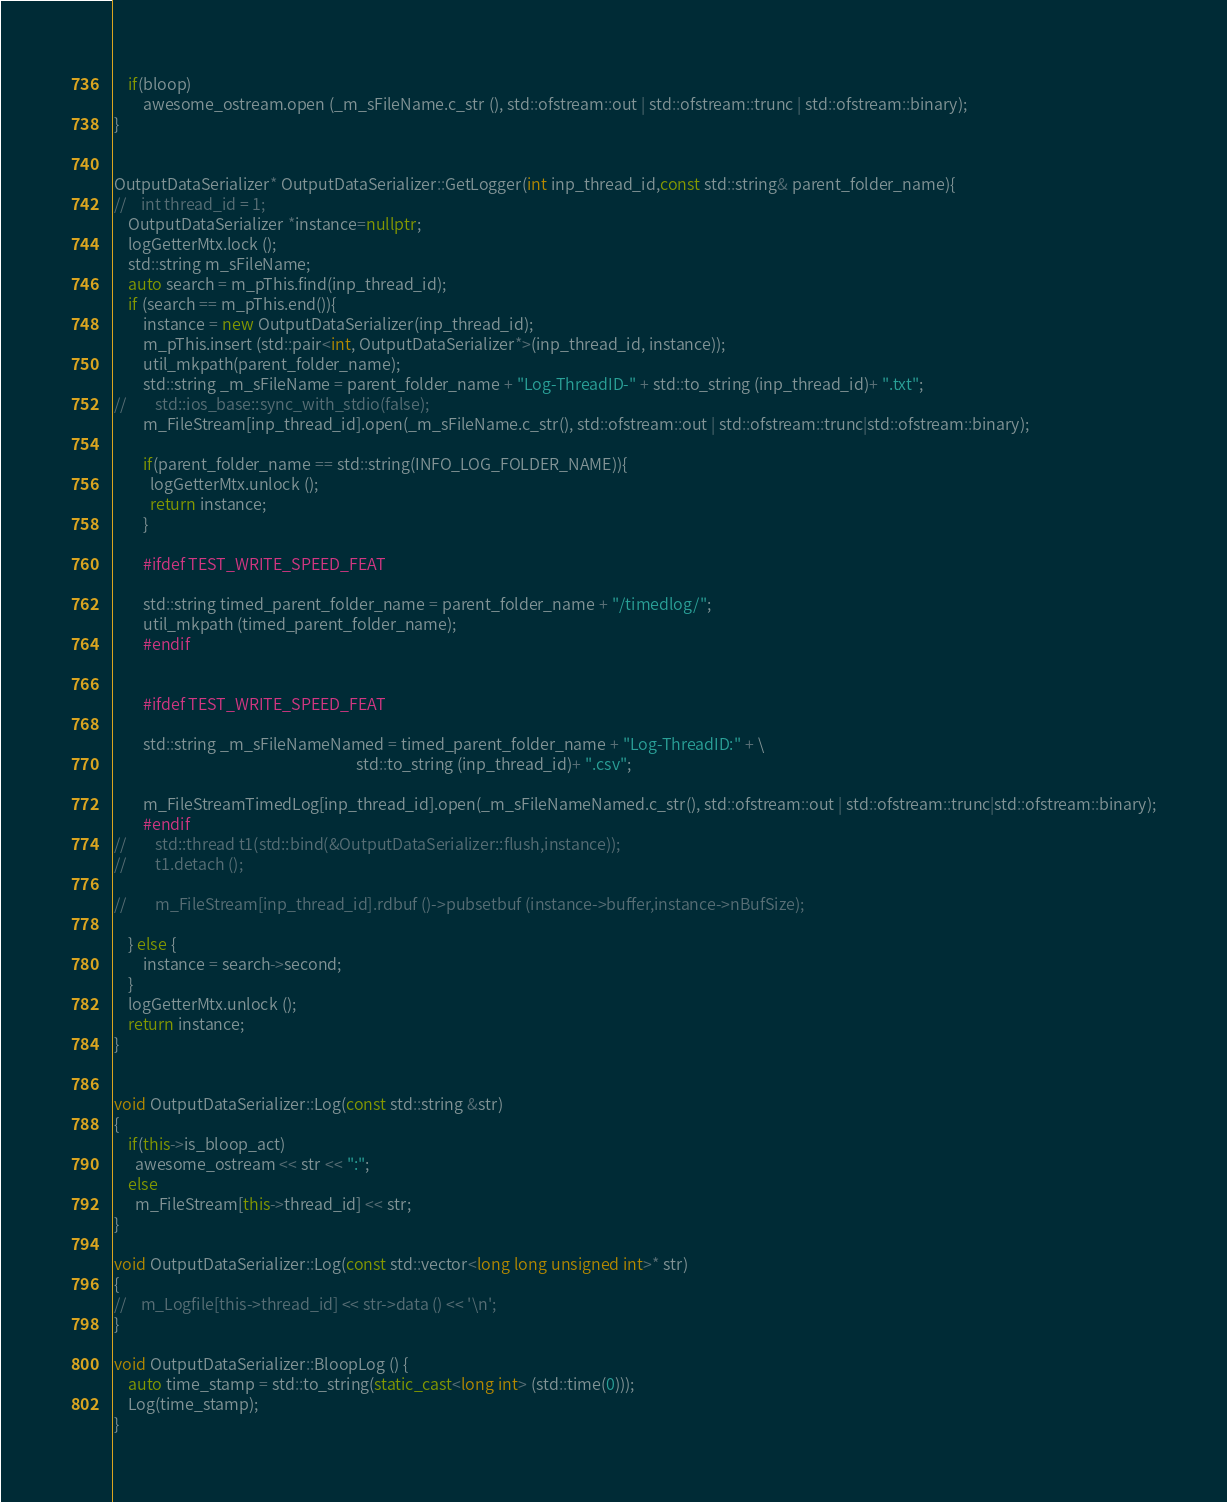<code> <loc_0><loc_0><loc_500><loc_500><_C++_>	if(bloop)
		awesome_ostream.open (_m_sFileName.c_str (), std::ofstream::out | std::ofstream::trunc | std::ofstream::binary);
}


OutputDataSerializer* OutputDataSerializer::GetLogger(int inp_thread_id,const std::string& parent_folder_name){
//    int thread_id = 1;
    OutputDataSerializer *instance=nullptr;
    logGetterMtx.lock ();
    std::string m_sFileName;
    auto search = m_pThis.find(inp_thread_id);
    if (search == m_pThis.end()){
        instance = new OutputDataSerializer(inp_thread_id);
        m_pThis.insert (std::pair<int, OutputDataSerializer*>(inp_thread_id, instance));
        util_mkpath(parent_folder_name);
        std::string _m_sFileName = parent_folder_name + "Log-ThreadID-" + std::to_string (inp_thread_id)+ ".txt";
//        std::ios_base::sync_with_stdio(false);
        m_FileStream[inp_thread_id].open(_m_sFileName.c_str(), std::ofstream::out | std::ofstream::trunc|std::ofstream::binary);
        
	  	if(parent_folder_name == std::string(INFO_LOG_FOLDER_NAME)){
	  	  logGetterMtx.unlock ();
	  	  return instance;
	  	}
	  
        #ifdef TEST_WRITE_SPEED_FEAT
        
        std::string timed_parent_folder_name = parent_folder_name + "/timedlog/";
        util_mkpath (timed_parent_folder_name);
        #endif
        
        
        #ifdef TEST_WRITE_SPEED_FEAT
        
        std::string _m_sFileNameNamed = timed_parent_folder_name + "Log-ThreadID:" + \
                                                                    std::to_string (inp_thread_id)+ ".csv";
        
        m_FileStreamTimedLog[inp_thread_id].open(_m_sFileNameNamed.c_str(), std::ofstream::out | std::ofstream::trunc|std::ofstream::binary);
		#endif
//        std::thread t1(std::bind(&OutputDataSerializer::flush,instance));
//        t1.detach ();

//        m_FileStream[inp_thread_id].rdbuf ()->pubsetbuf (instance->buffer,instance->nBufSize);

    } else {
        instance = search->second;
    }
    logGetterMtx.unlock ();
    return instance;
}


void OutputDataSerializer::Log(const std::string &str)
{
  	if(this->is_bloop_act)
  	  awesome_ostream << str << ":";
  	else
  	  m_FileStream[this->thread_id] << str;
}

void OutputDataSerializer::Log(const std::vector<long long unsigned int>* str)
{
//    m_Logfile[this->thread_id] << str->data () << '\n';
}

void OutputDataSerializer::BloopLog () {
  	auto time_stamp = std::to_string(static_cast<long int> (std::time(0)));
    Log(time_stamp);
}
</code> 